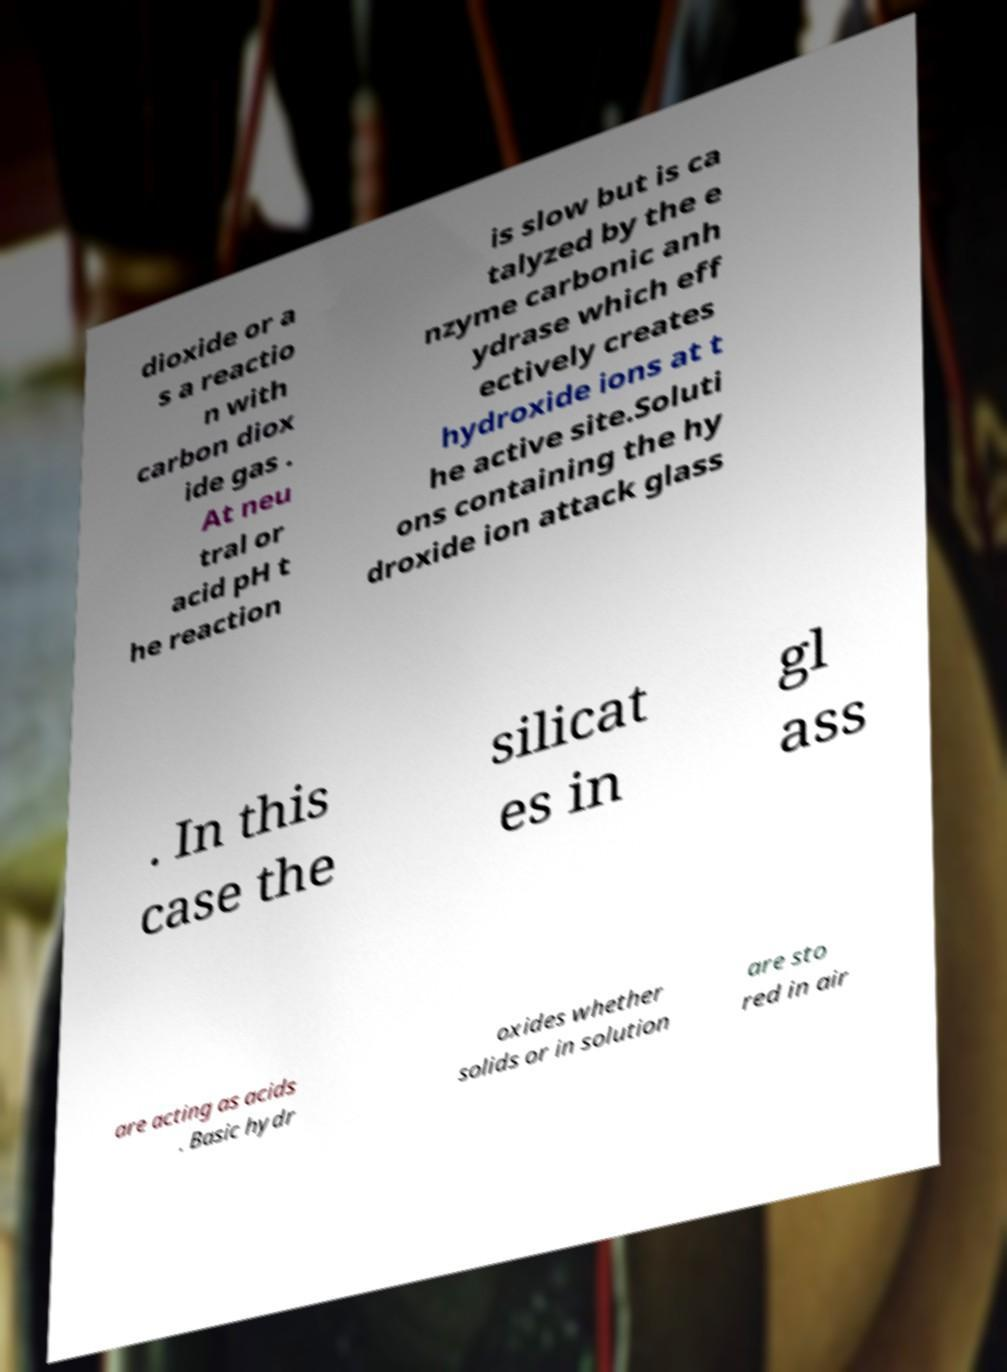I need the written content from this picture converted into text. Can you do that? dioxide or a s a reactio n with carbon diox ide gas . At neu tral or acid pH t he reaction is slow but is ca talyzed by the e nzyme carbonic anh ydrase which eff ectively creates hydroxide ions at t he active site.Soluti ons containing the hy droxide ion attack glass . In this case the silicat es in gl ass are acting as acids . Basic hydr oxides whether solids or in solution are sto red in air 